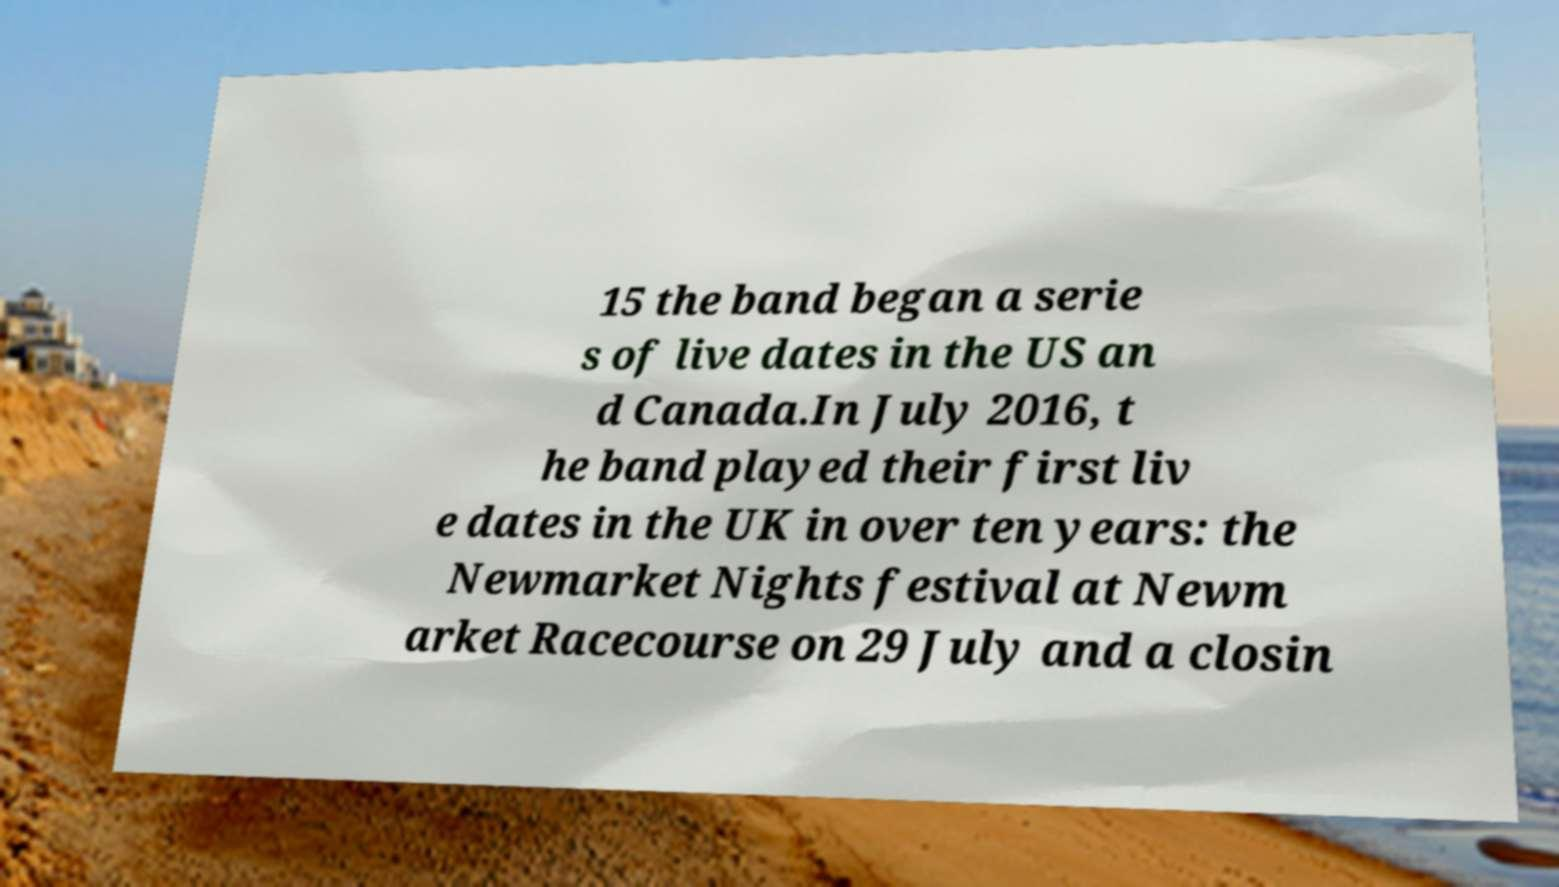Could you extract and type out the text from this image? 15 the band began a serie s of live dates in the US an d Canada.In July 2016, t he band played their first liv e dates in the UK in over ten years: the Newmarket Nights festival at Newm arket Racecourse on 29 July and a closin 